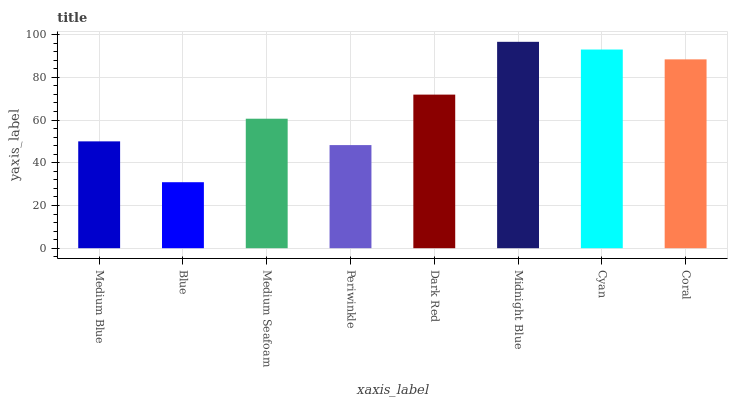Is Blue the minimum?
Answer yes or no. Yes. Is Midnight Blue the maximum?
Answer yes or no. Yes. Is Medium Seafoam the minimum?
Answer yes or no. No. Is Medium Seafoam the maximum?
Answer yes or no. No. Is Medium Seafoam greater than Blue?
Answer yes or no. Yes. Is Blue less than Medium Seafoam?
Answer yes or no. Yes. Is Blue greater than Medium Seafoam?
Answer yes or no. No. Is Medium Seafoam less than Blue?
Answer yes or no. No. Is Dark Red the high median?
Answer yes or no. Yes. Is Medium Seafoam the low median?
Answer yes or no. Yes. Is Midnight Blue the high median?
Answer yes or no. No. Is Midnight Blue the low median?
Answer yes or no. No. 